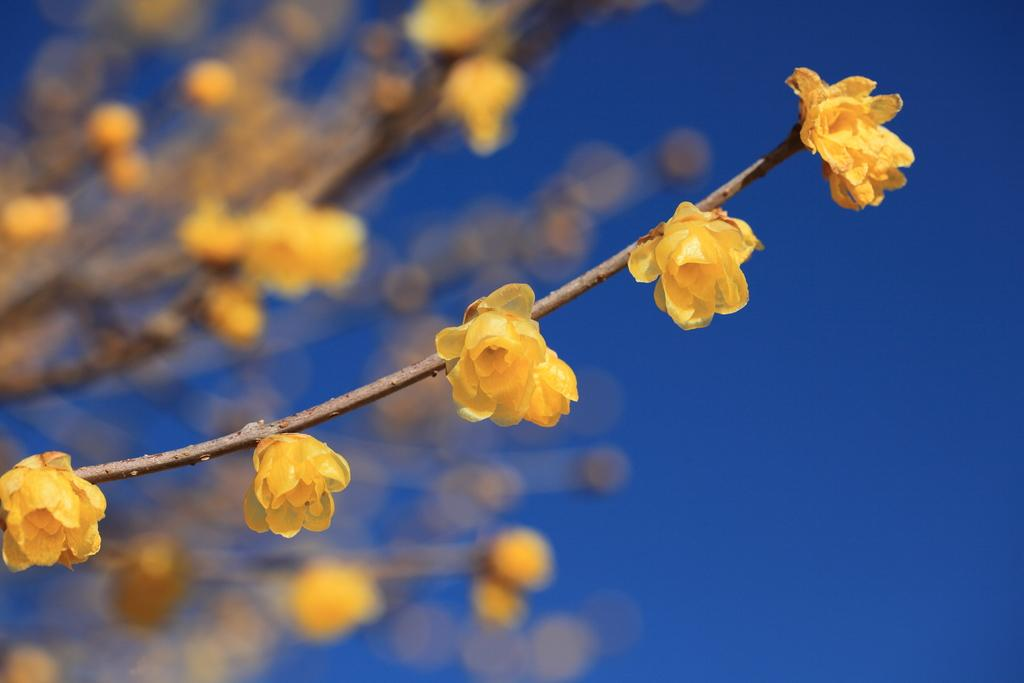What type of plant can be seen in the image? There is a tree in the image. What is the color of the tree? The tree is brown in color. Are there any flowers on the tree? Yes, there are flowers on the tree. What is the color of the flowers? The flowers are yellow in color. What can be seen in the background of the image? The sky is visible in the background of the image. What is the color of the sky? The sky is blue in color. What type of oil can be seen dripping from the tree in the image? There is no oil present in the image; it features a tree with yellow flowers and a blue sky in the background. 